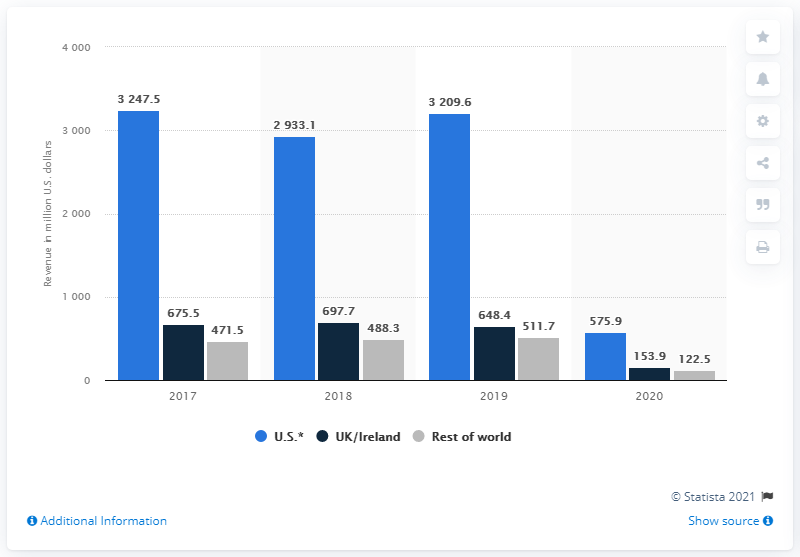Specify some key components in this picture. In 2020, Cineworld Group's global revenue was 575.9 million dollars. 